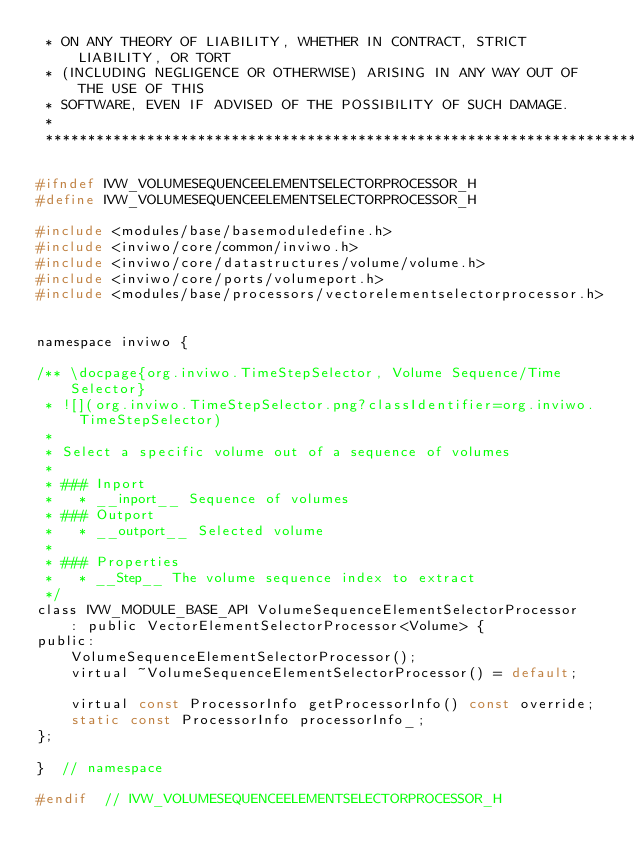Convert code to text. <code><loc_0><loc_0><loc_500><loc_500><_C_> * ON ANY THEORY OF LIABILITY, WHETHER IN CONTRACT, STRICT LIABILITY, OR TORT
 * (INCLUDING NEGLIGENCE OR OTHERWISE) ARISING IN ANY WAY OUT OF THE USE OF THIS
 * SOFTWARE, EVEN IF ADVISED OF THE POSSIBILITY OF SUCH DAMAGE.
 *
 *********************************************************************************/

#ifndef IVW_VOLUMESEQUENCEELEMENTSELECTORPROCESSOR_H
#define IVW_VOLUMESEQUENCEELEMENTSELECTORPROCESSOR_H

#include <modules/base/basemoduledefine.h>
#include <inviwo/core/common/inviwo.h>
#include <inviwo/core/datastructures/volume/volume.h>
#include <inviwo/core/ports/volumeport.h>
#include <modules/base/processors/vectorelementselectorprocessor.h>


namespace inviwo {

/** \docpage{org.inviwo.TimeStepSelector, Volume Sequence/Time Selector}
 * ![](org.inviwo.TimeStepSelector.png?classIdentifier=org.inviwo.TimeStepSelector)
 *
 * Select a specific volume out of a sequence of volumes
 *
 * ### Inport
 *   * __inport__ Sequence of volumes
 * ### Outport
 *   * __outport__ Selected volume
 *
 * ### Properties
 *   * __Step__ The volume sequence index to extract
 */
class IVW_MODULE_BASE_API VolumeSequenceElementSelectorProcessor
    : public VectorElementSelectorProcessor<Volume> {
public:
    VolumeSequenceElementSelectorProcessor();
    virtual ~VolumeSequenceElementSelectorProcessor() = default;

    virtual const ProcessorInfo getProcessorInfo() const override;
    static const ProcessorInfo processorInfo_;
};

}  // namespace

#endif  // IVW_VOLUMESEQUENCEELEMENTSELECTORPROCESSOR_H
</code> 